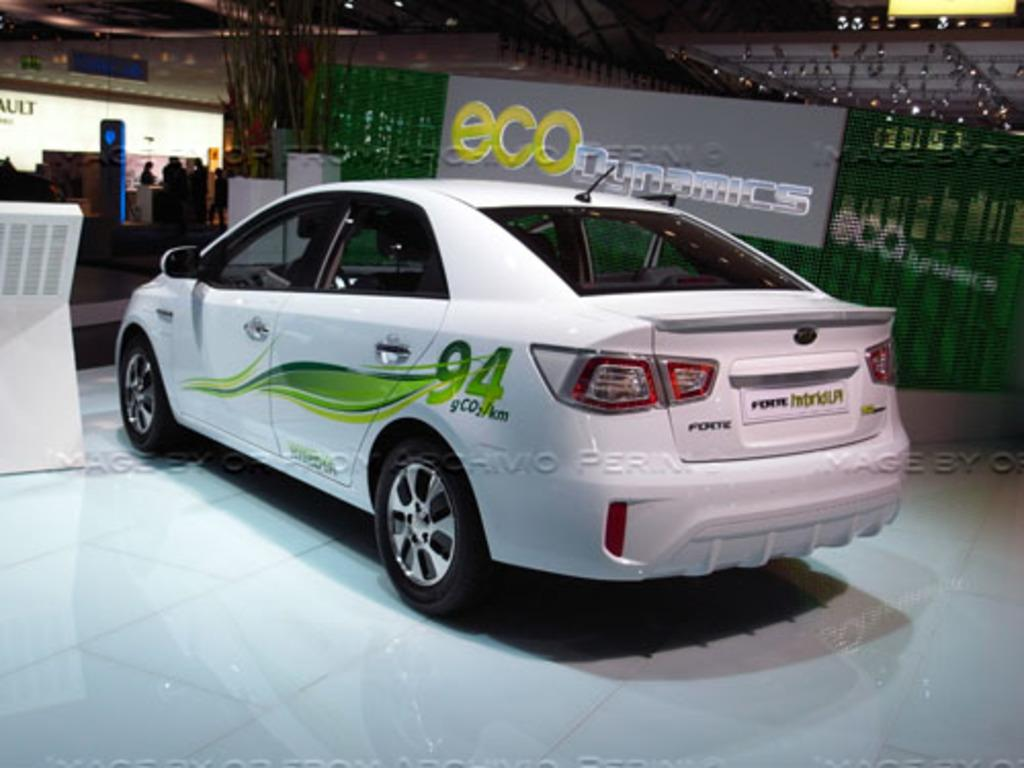What is the main subject of the image? There is a car in the image. Can you describe the car's appearance? The car is white. What can be seen in the background of the image? There is a gray color board attached to the railing, a wall that is white, and people standing in the background. What is the name of the person sleeping in the bedroom in the image? There is no bedroom or person sleeping in the image; it features a white car and a background with a gray color board, a white wall, and people standing. 